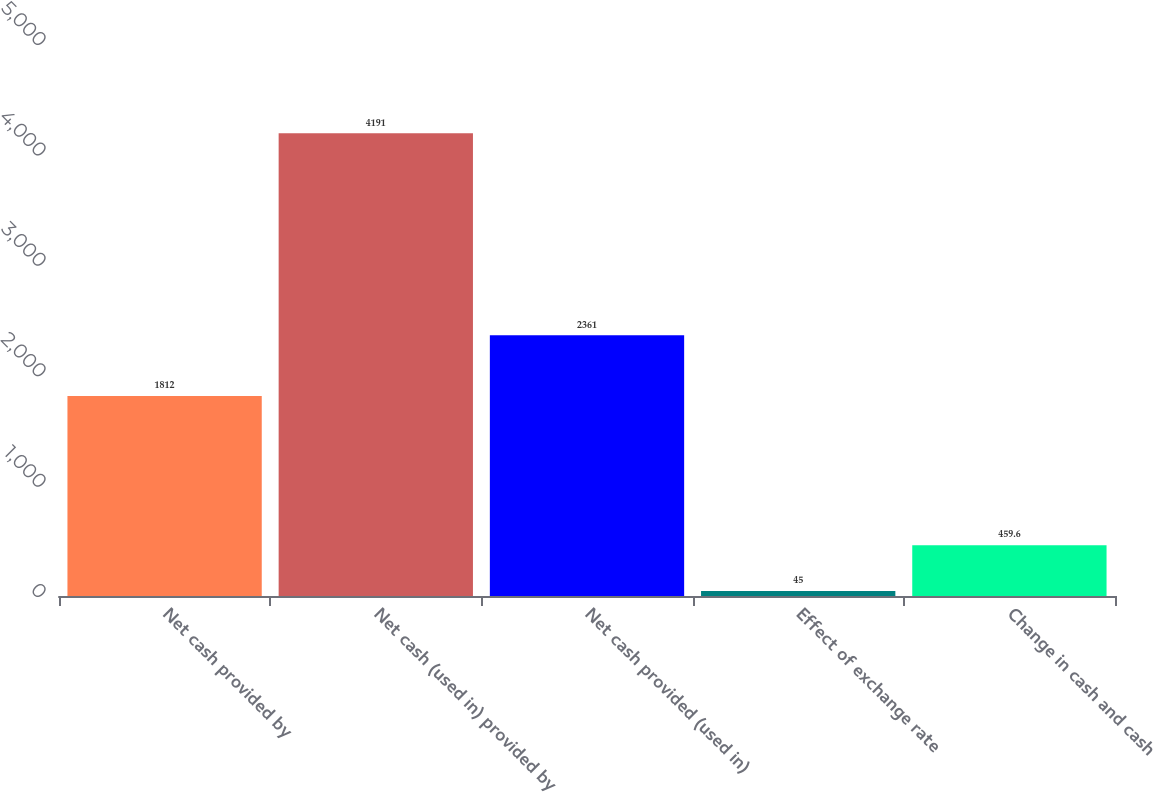<chart> <loc_0><loc_0><loc_500><loc_500><bar_chart><fcel>Net cash provided by<fcel>Net cash (used in) provided by<fcel>Net cash provided (used in)<fcel>Effect of exchange rate<fcel>Change in cash and cash<nl><fcel>1812<fcel>4191<fcel>2361<fcel>45<fcel>459.6<nl></chart> 